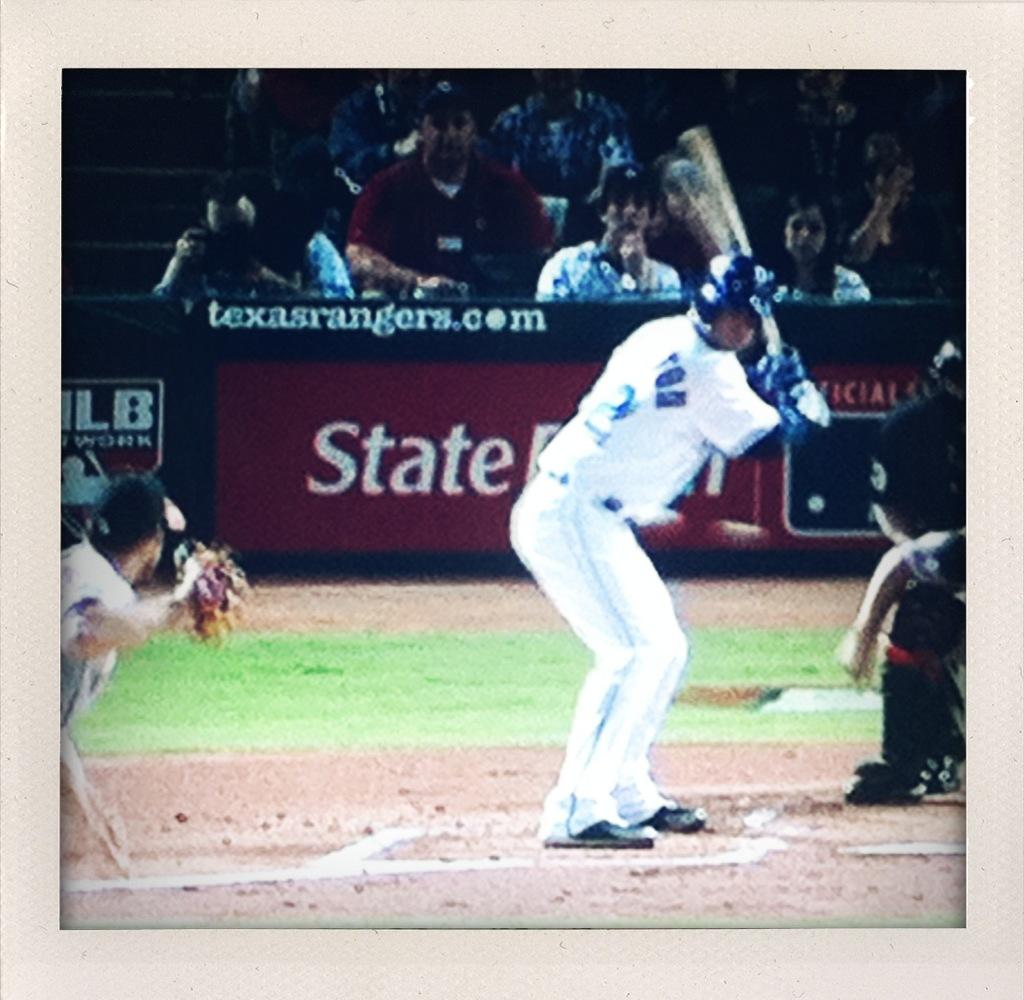<image>
Describe the image concisely. A batter at a baseball game gets ready to swing in front of an ad for texasrangers.com 